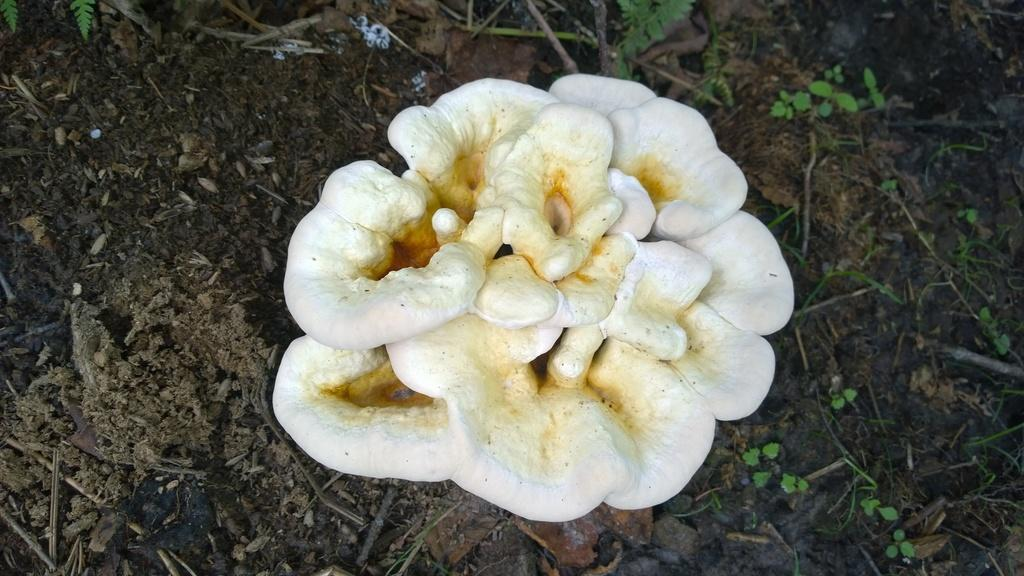What is the main subject in the center of the image? There are mushrooms in the center of the image. What type of surface can be seen at the bottom of the image? There is ground visible at the bottom of the image. Where is the zipper located in the image? There is no zipper present in the image. What type of bread can be seen in the image? There is no loaf of bread present in the image. 